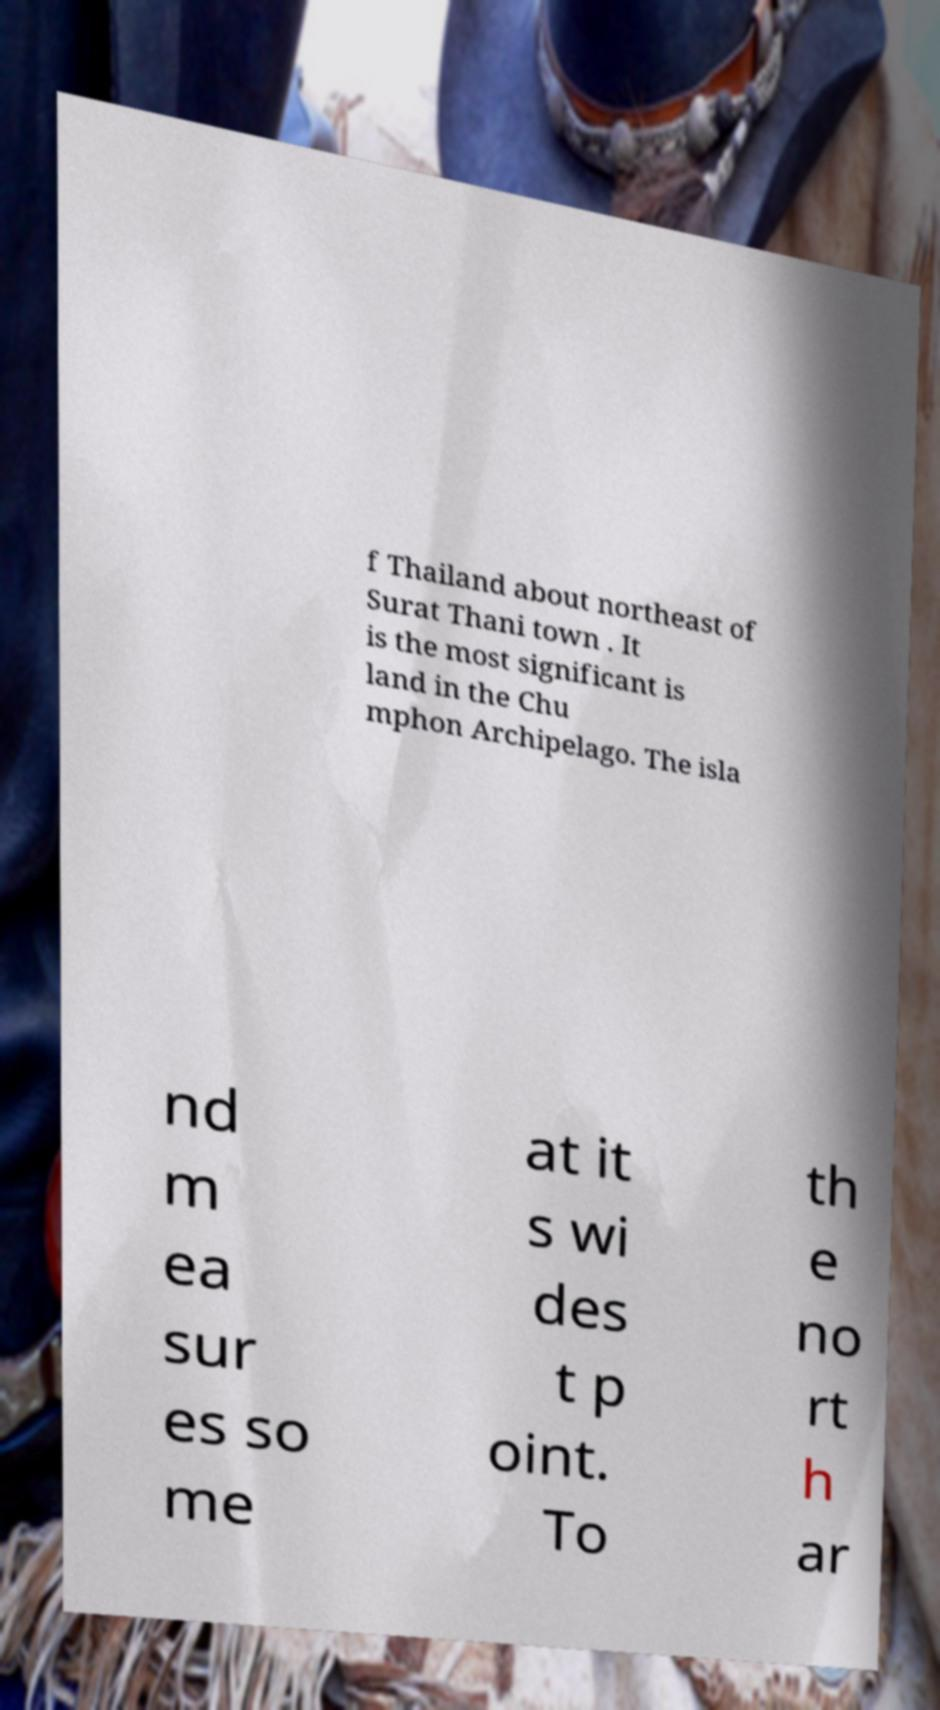I need the written content from this picture converted into text. Can you do that? f Thailand about northeast of Surat Thani town . It is the most significant is land in the Chu mphon Archipelago. The isla nd m ea sur es so me at it s wi des t p oint. To th e no rt h ar 